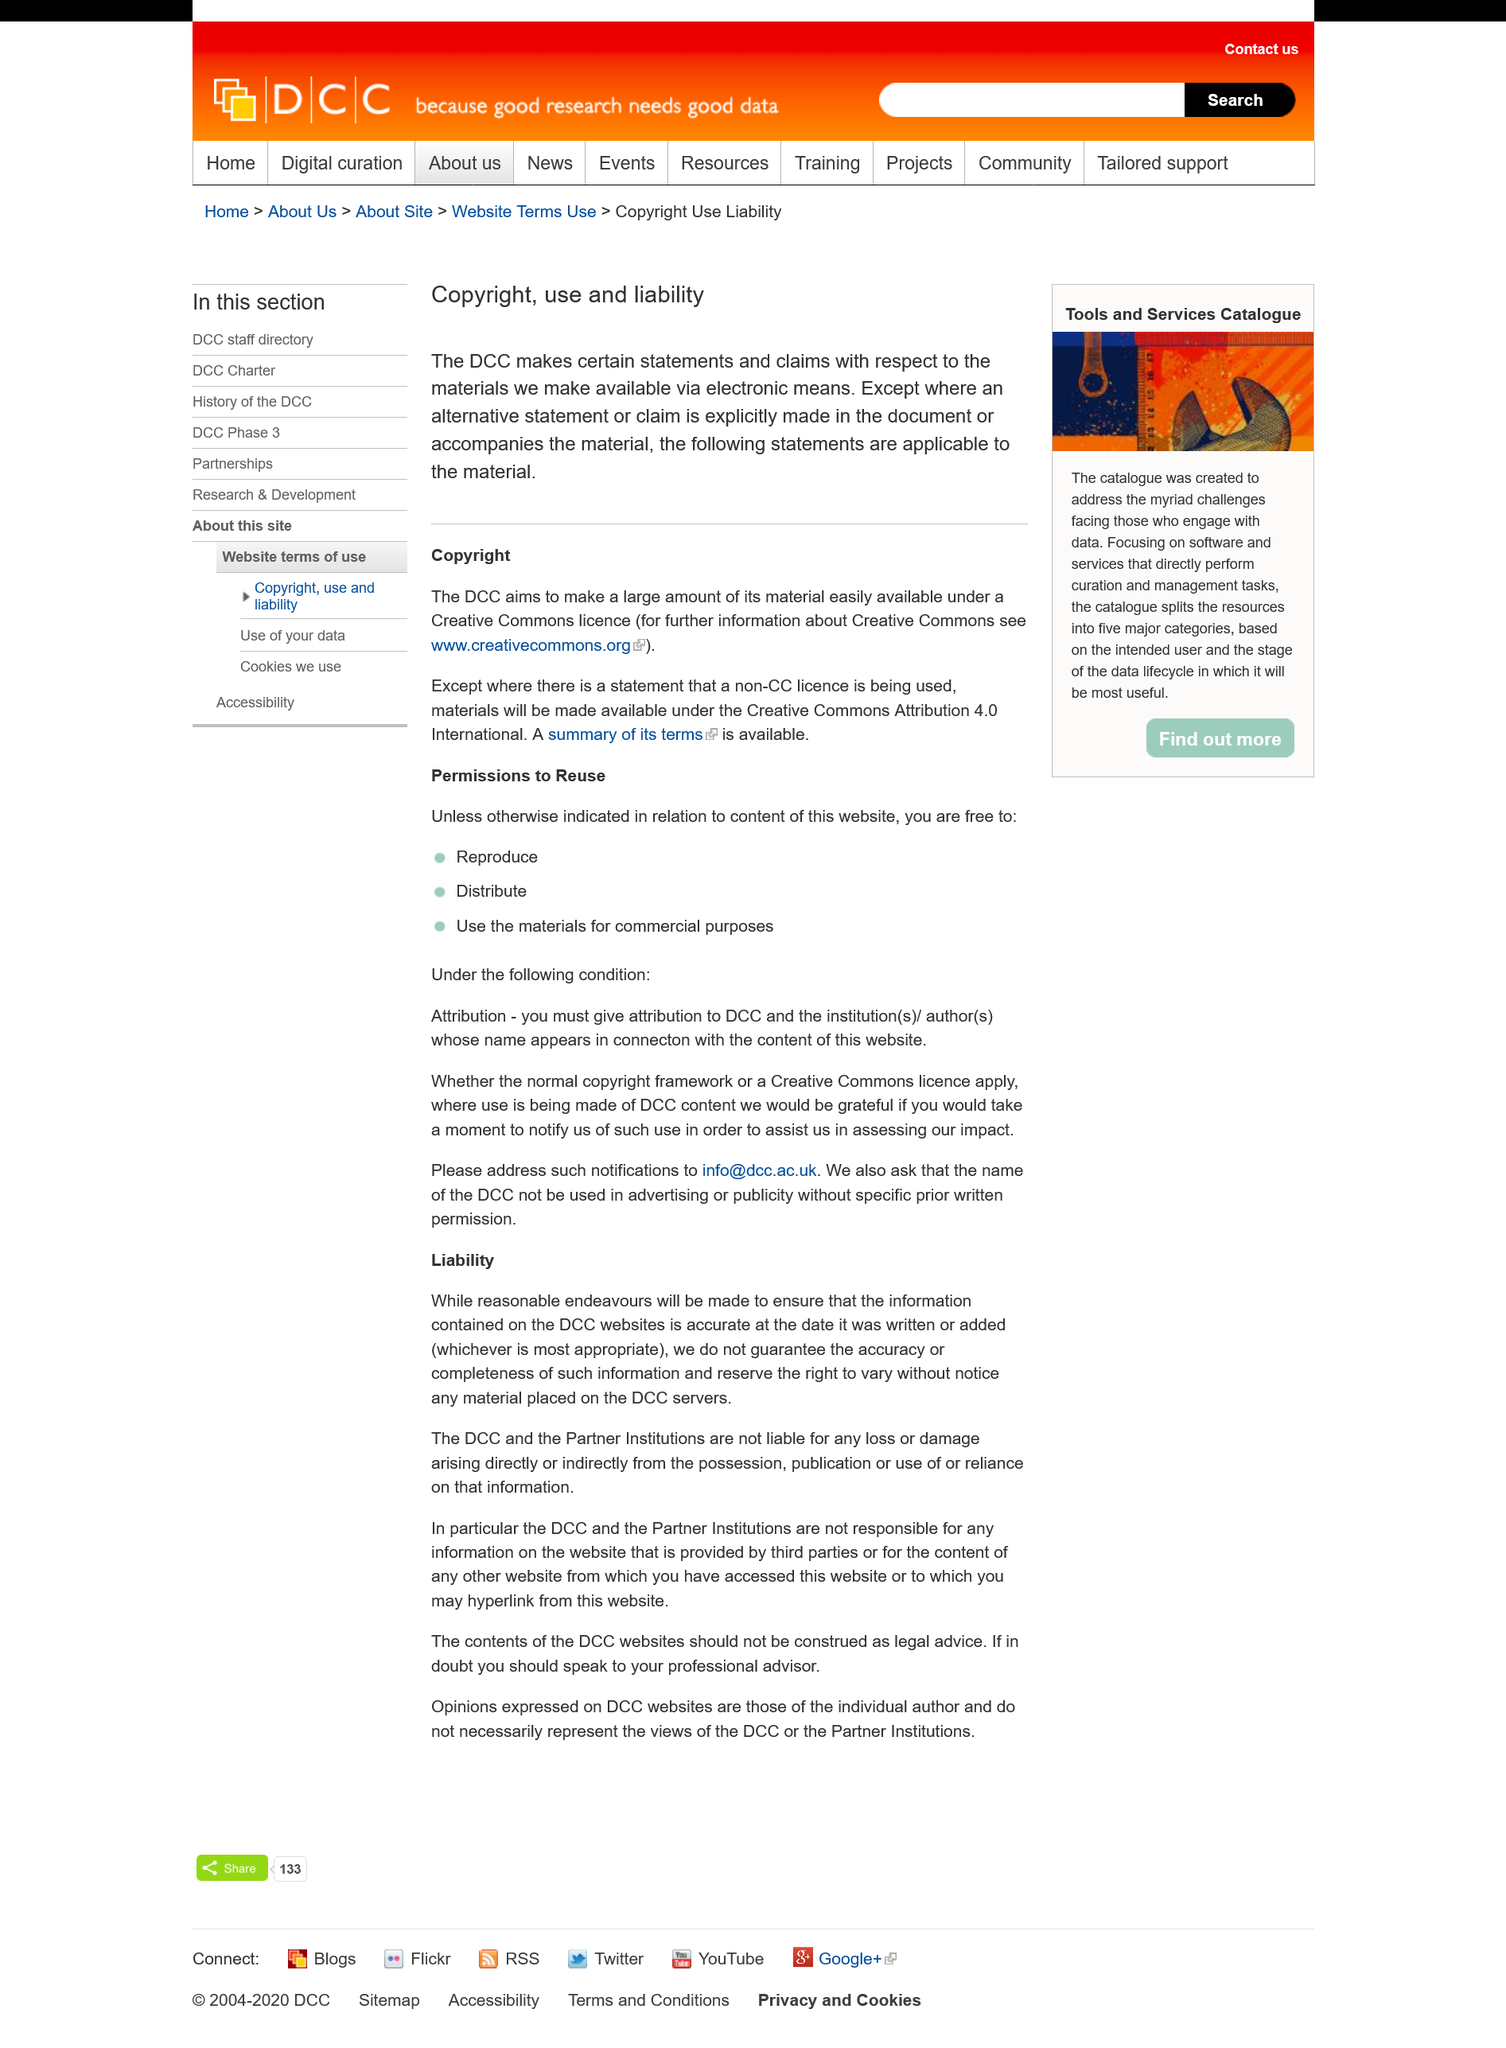Draw attention to some important aspects in this diagram. The DCC aims to make a significant portion of its material available under a Creative Commons license, making it easily accessible to the public. The DCC aims to make a significant portion of its material available under a Creative Commons license for easy access. 